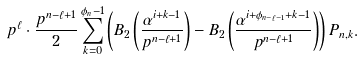Convert formula to latex. <formula><loc_0><loc_0><loc_500><loc_500>p ^ { \ell } \cdot \frac { p ^ { n - \ell + 1 } } 2 \sum _ { k = 0 } ^ { \phi _ { n } - 1 } \left ( B _ { 2 } \left ( \frac { \alpha ^ { i + k - 1 } } { p ^ { n - \ell + 1 } } \right ) - B _ { 2 } \left ( \frac { \alpha ^ { i + \phi _ { n - \ell - 1 } + k - 1 } } { p ^ { n - \ell + 1 } } \right ) \right ) P _ { n , k } .</formula> 